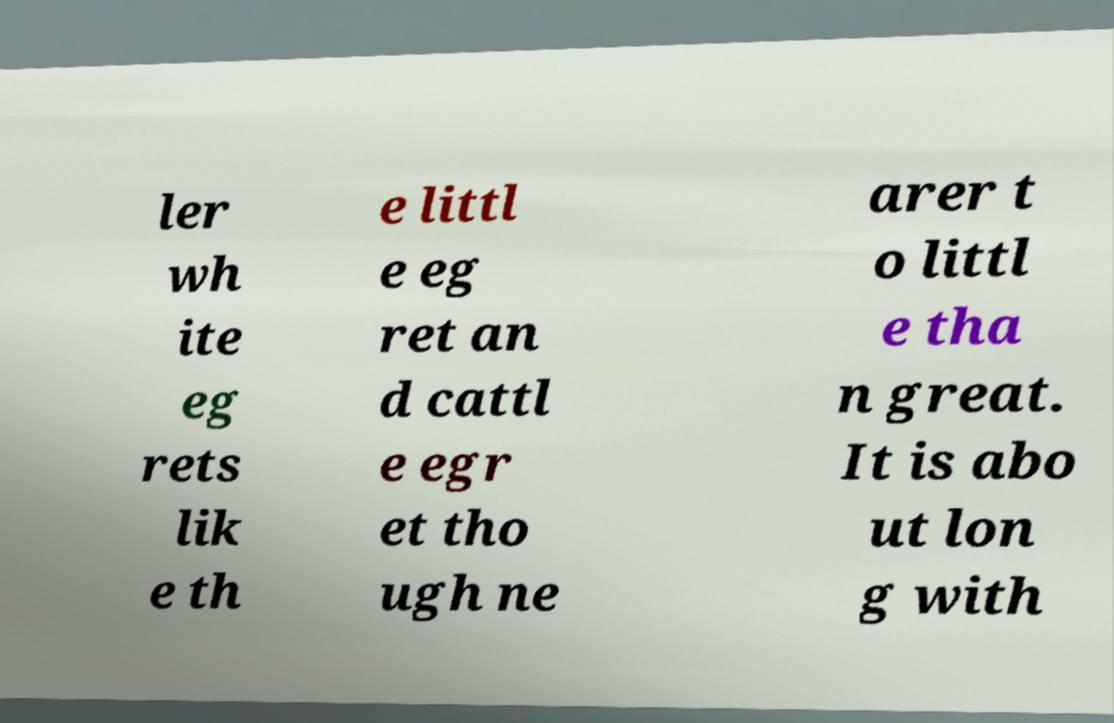For documentation purposes, I need the text within this image transcribed. Could you provide that? ler wh ite eg rets lik e th e littl e eg ret an d cattl e egr et tho ugh ne arer t o littl e tha n great. It is abo ut lon g with 